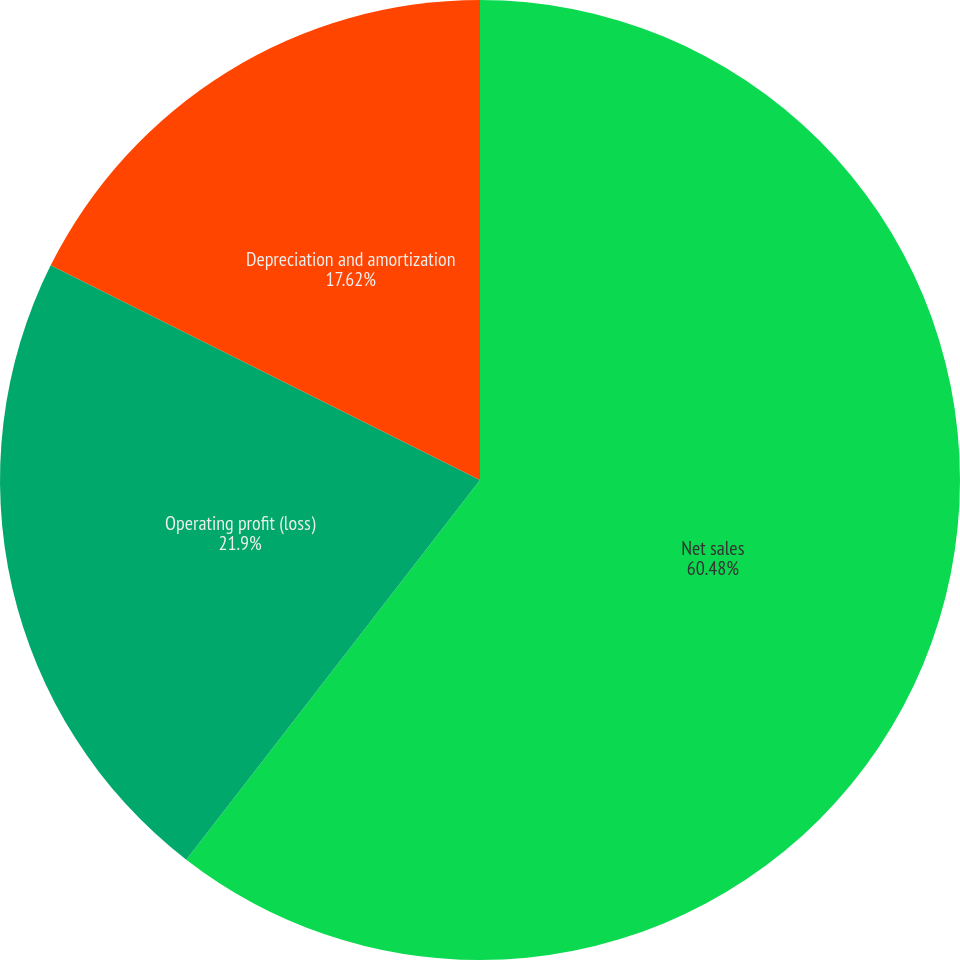Convert chart. <chart><loc_0><loc_0><loc_500><loc_500><pie_chart><fcel>Net sales<fcel>Operating profit (loss)<fcel>Depreciation and amortization<nl><fcel>60.48%<fcel>21.9%<fcel>17.62%<nl></chart> 